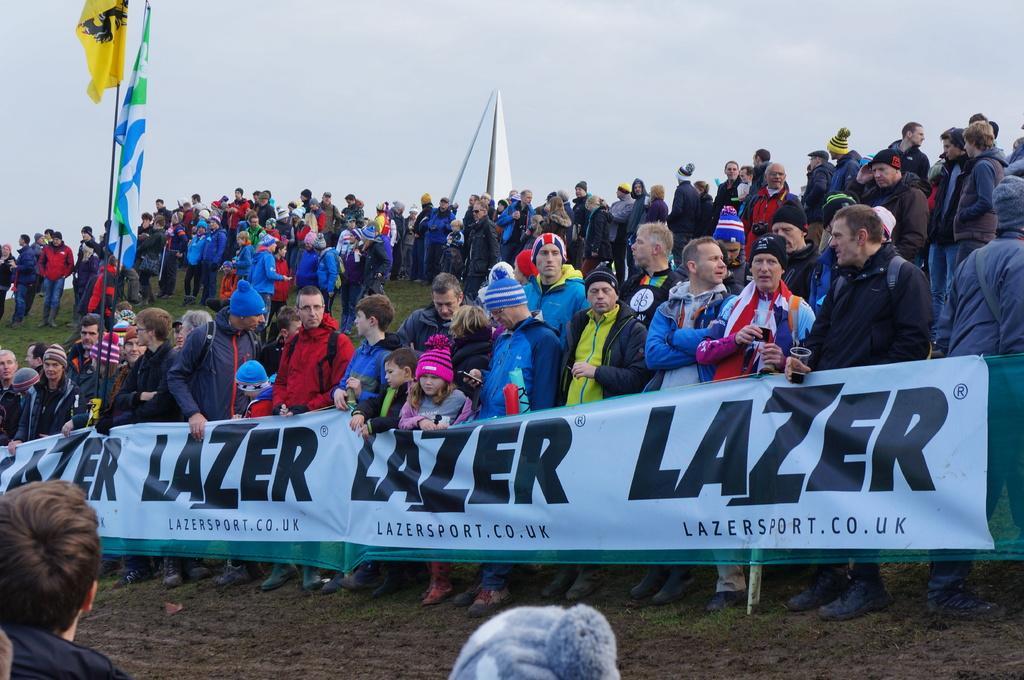Describe this image in one or two sentences. In this image we can see a few people, among them some people are carrying banner, there are some flags and in the background we can see the sky. 